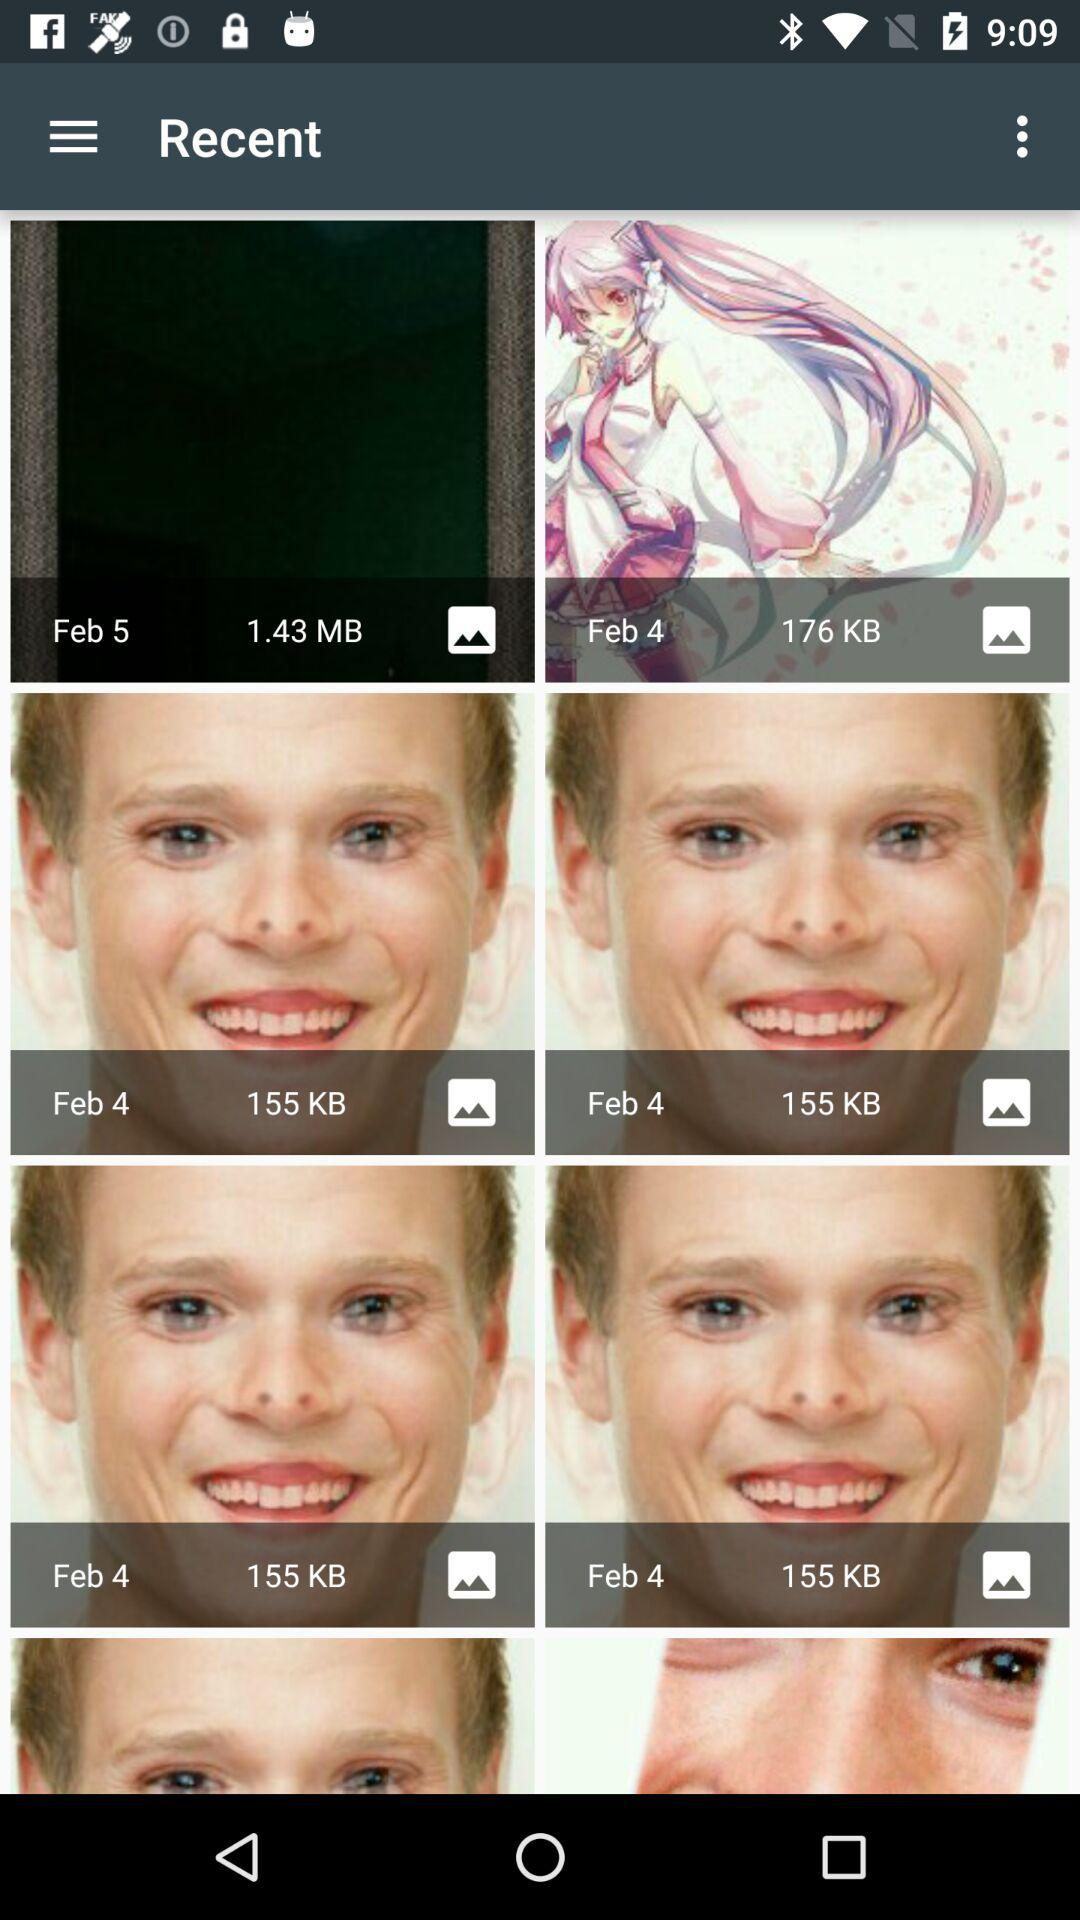On which date were the 155 KB pictures clicked? The 155 KB pictures were clicked on February 4. 